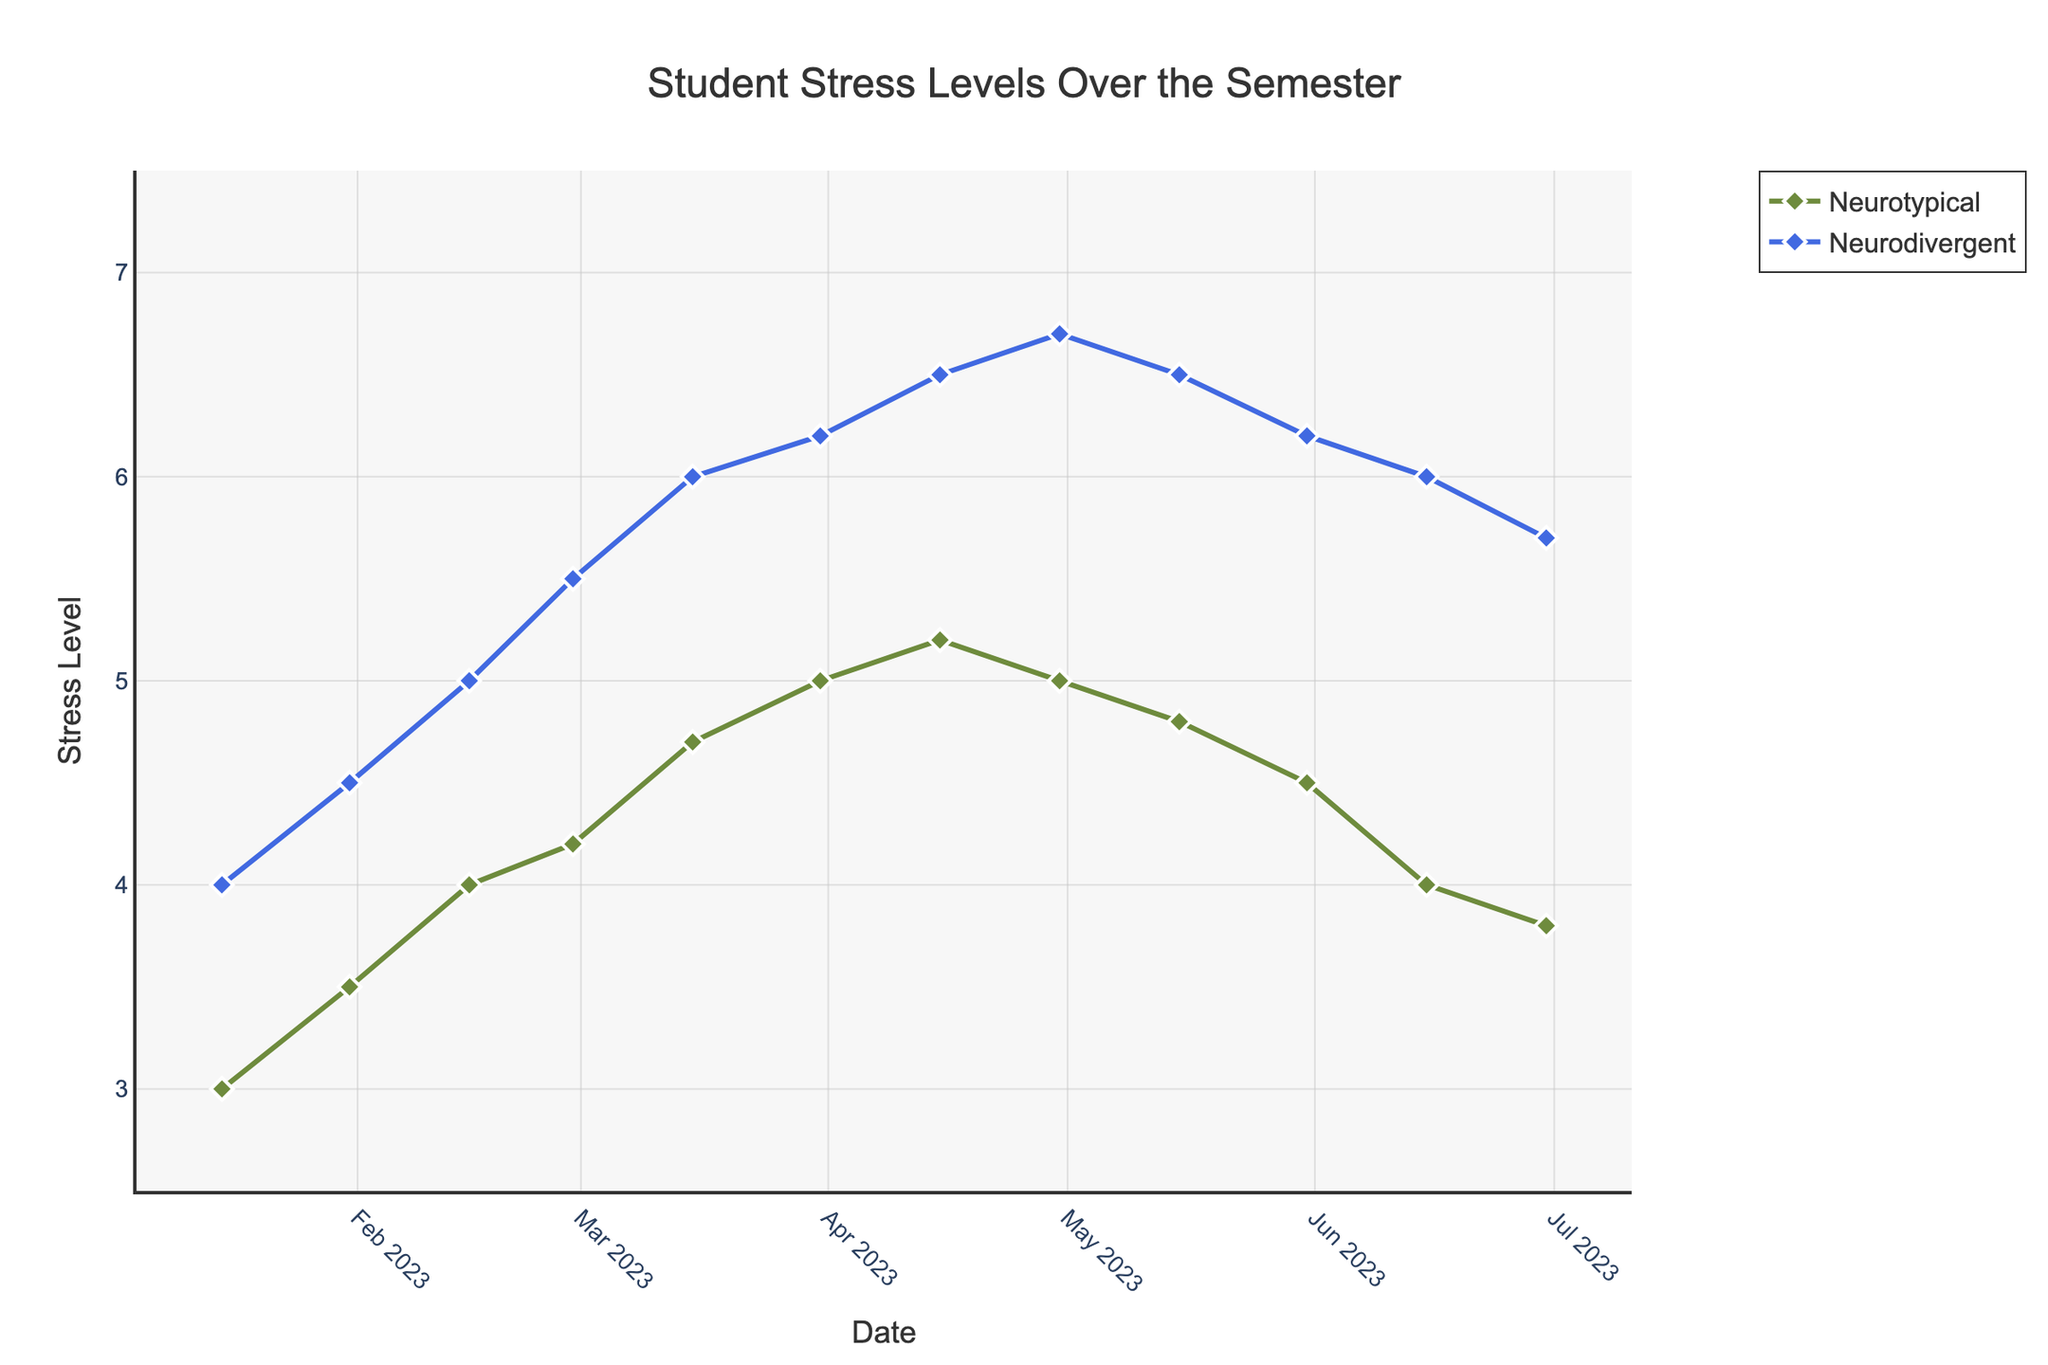How does the stress level for neurotypical students change from January to June? From January to June, the stress level for neurotypical students first increases, peaking in mid-April, and then begins to decrease again towards the end of the semester.
Answer: It increases then decreases Which group has a higher stress level in mid-March? By looking at the mid-March data points, the neurodivergent group has a stress level of 6, while the neurotypical group has a stress level of 4.7.
Answer: Neurodivergent What is the highest recorded stress level for neurodivergent students? The highest recorded stress level for neurodivergent students is observed in late April with a value of 6.7.
Answer: 6.7 How many times did stress levels for neurotypical students decrease over the semester? Stress levels for neurotypical students decreased from late April to early May, mid-May to late May, late May to mid-June, and mid-June to late June. Counting these periods gives four times.
Answer: 4 During which period did both neurotypical and neurodivergent students have the closest stress levels? Comparing the difference in stress levels at each time point, the smallest difference is observed at the end of January when neurotypical students have a stress level of 3.5 and neurodivergent students have 4.5, a difference of 1.
Answer: End of January What's the average stress level for neurotypical students over the entire semester? Sum the stress levels for neurotypical students: 3+3.5+4+4.2+4.7+5+5.2+5+4.8+4.5+4+3.8 = 51.7. There are 12 data points, so the average is 51.7/12 = 4.31.
Answer: 4.31 Is the trend in stress levels for neurodivergent students consistent throughout the semester? The trend for neurodivergent students shows a consistent increase in stress levels from January to April, then it remains high with slight fluctuations.
Answer: Consistent increase then high with fluctuations Describe the variation in stress levels for neurotypical students between March and April. From March to April, stress levels for neurotypical students increase steadily from 4.7 (mid-March) to 5.2 (mid-April), reaching a peak, then start to slightly decline.
Answer: Increase then peak What is the difference in stress levels between the two groups at the end of June? At the end of June, the stress level for neurotypical students is 3.8, and for neurodivergent students is 5.7. The difference is 5.7 - 3.8 = 1.9.
Answer: 1.9 